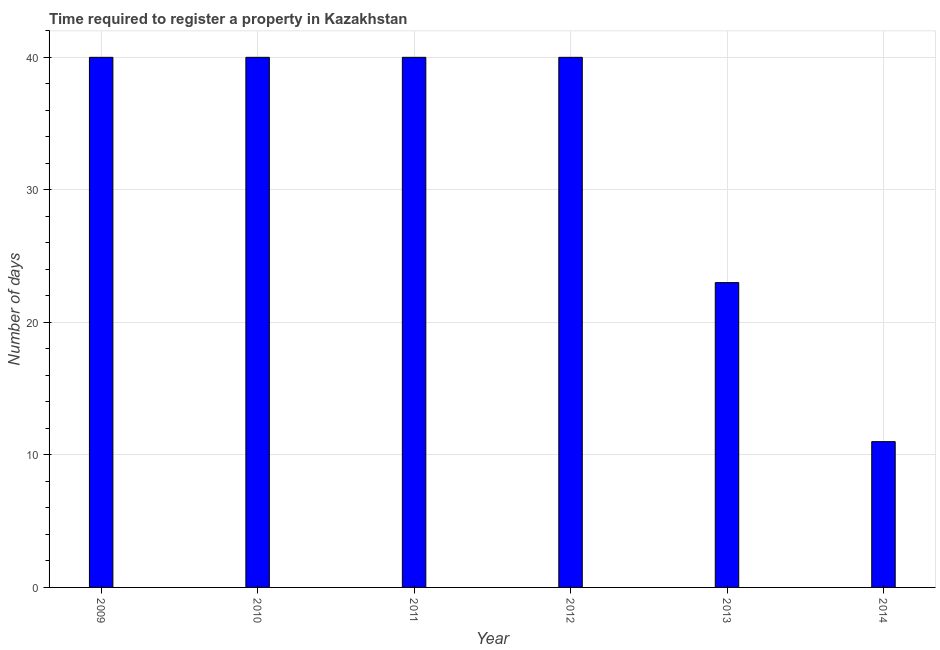Does the graph contain any zero values?
Offer a terse response. No. Does the graph contain grids?
Your answer should be very brief. Yes. What is the title of the graph?
Provide a succinct answer. Time required to register a property in Kazakhstan. What is the label or title of the Y-axis?
Provide a succinct answer. Number of days. Across all years, what is the maximum number of days required to register property?
Provide a succinct answer. 40. Across all years, what is the minimum number of days required to register property?
Your answer should be very brief. 11. In which year was the number of days required to register property maximum?
Give a very brief answer. 2009. What is the sum of the number of days required to register property?
Keep it short and to the point. 194. What is the difference between the number of days required to register property in 2010 and 2012?
Offer a terse response. 0. What is the average number of days required to register property per year?
Offer a very short reply. 32.33. What is the median number of days required to register property?
Ensure brevity in your answer.  40. In how many years, is the number of days required to register property greater than 32 days?
Keep it short and to the point. 4. What is the ratio of the number of days required to register property in 2011 to that in 2014?
Ensure brevity in your answer.  3.64. Is the difference between the number of days required to register property in 2009 and 2010 greater than the difference between any two years?
Your response must be concise. No. Is the sum of the number of days required to register property in 2010 and 2011 greater than the maximum number of days required to register property across all years?
Give a very brief answer. Yes. In how many years, is the number of days required to register property greater than the average number of days required to register property taken over all years?
Ensure brevity in your answer.  4. How many years are there in the graph?
Ensure brevity in your answer.  6. What is the Number of days of 2009?
Ensure brevity in your answer.  40. What is the Number of days in 2010?
Provide a succinct answer. 40. What is the Number of days in 2013?
Keep it short and to the point. 23. What is the difference between the Number of days in 2009 and 2010?
Offer a terse response. 0. What is the difference between the Number of days in 2009 and 2013?
Your response must be concise. 17. What is the difference between the Number of days in 2009 and 2014?
Your answer should be compact. 29. What is the difference between the Number of days in 2010 and 2011?
Give a very brief answer. 0. What is the difference between the Number of days in 2010 and 2012?
Keep it short and to the point. 0. What is the difference between the Number of days in 2010 and 2013?
Give a very brief answer. 17. What is the difference between the Number of days in 2011 and 2012?
Offer a terse response. 0. What is the difference between the Number of days in 2012 and 2013?
Your answer should be very brief. 17. What is the difference between the Number of days in 2012 and 2014?
Offer a very short reply. 29. What is the difference between the Number of days in 2013 and 2014?
Make the answer very short. 12. What is the ratio of the Number of days in 2009 to that in 2010?
Make the answer very short. 1. What is the ratio of the Number of days in 2009 to that in 2011?
Your response must be concise. 1. What is the ratio of the Number of days in 2009 to that in 2012?
Your answer should be very brief. 1. What is the ratio of the Number of days in 2009 to that in 2013?
Your answer should be very brief. 1.74. What is the ratio of the Number of days in 2009 to that in 2014?
Your answer should be very brief. 3.64. What is the ratio of the Number of days in 2010 to that in 2011?
Provide a short and direct response. 1. What is the ratio of the Number of days in 2010 to that in 2012?
Provide a short and direct response. 1. What is the ratio of the Number of days in 2010 to that in 2013?
Your answer should be very brief. 1.74. What is the ratio of the Number of days in 2010 to that in 2014?
Offer a very short reply. 3.64. What is the ratio of the Number of days in 2011 to that in 2013?
Give a very brief answer. 1.74. What is the ratio of the Number of days in 2011 to that in 2014?
Keep it short and to the point. 3.64. What is the ratio of the Number of days in 2012 to that in 2013?
Your answer should be compact. 1.74. What is the ratio of the Number of days in 2012 to that in 2014?
Offer a very short reply. 3.64. What is the ratio of the Number of days in 2013 to that in 2014?
Make the answer very short. 2.09. 